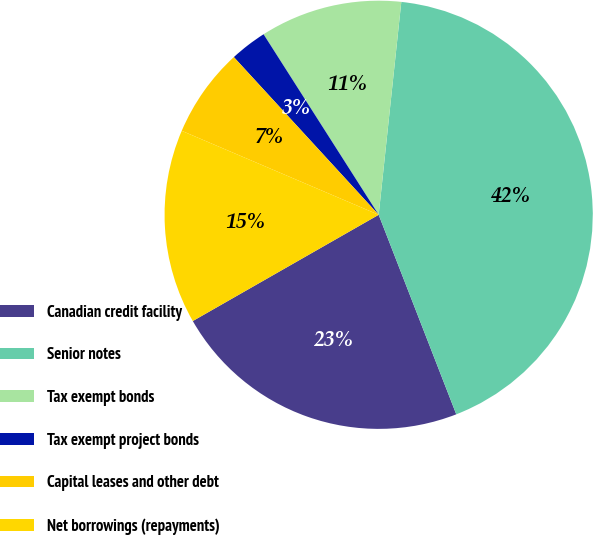Convert chart to OTSL. <chart><loc_0><loc_0><loc_500><loc_500><pie_chart><fcel>Canadian credit facility<fcel>Senior notes<fcel>Tax exempt bonds<fcel>Tax exempt project bonds<fcel>Capital leases and other debt<fcel>Net borrowings (repayments)<nl><fcel>22.64%<fcel>42.41%<fcel>10.72%<fcel>2.79%<fcel>6.76%<fcel>14.68%<nl></chart> 